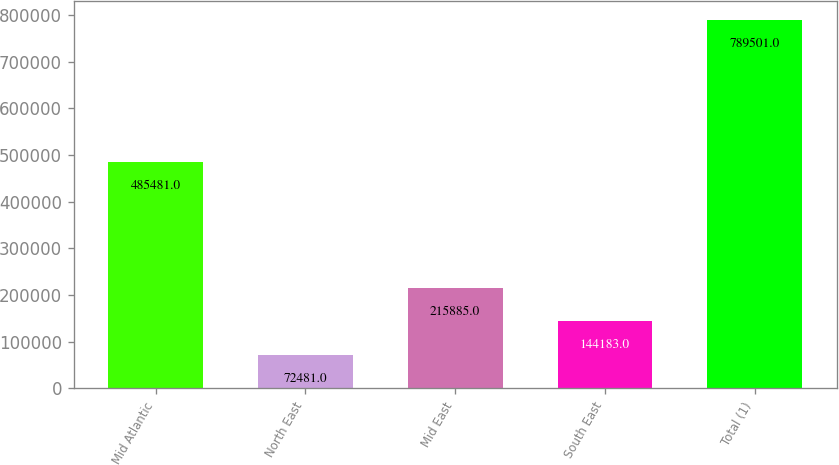<chart> <loc_0><loc_0><loc_500><loc_500><bar_chart><fcel>Mid Atlantic<fcel>North East<fcel>Mid East<fcel>South East<fcel>Total (1)<nl><fcel>485481<fcel>72481<fcel>215885<fcel>144183<fcel>789501<nl></chart> 